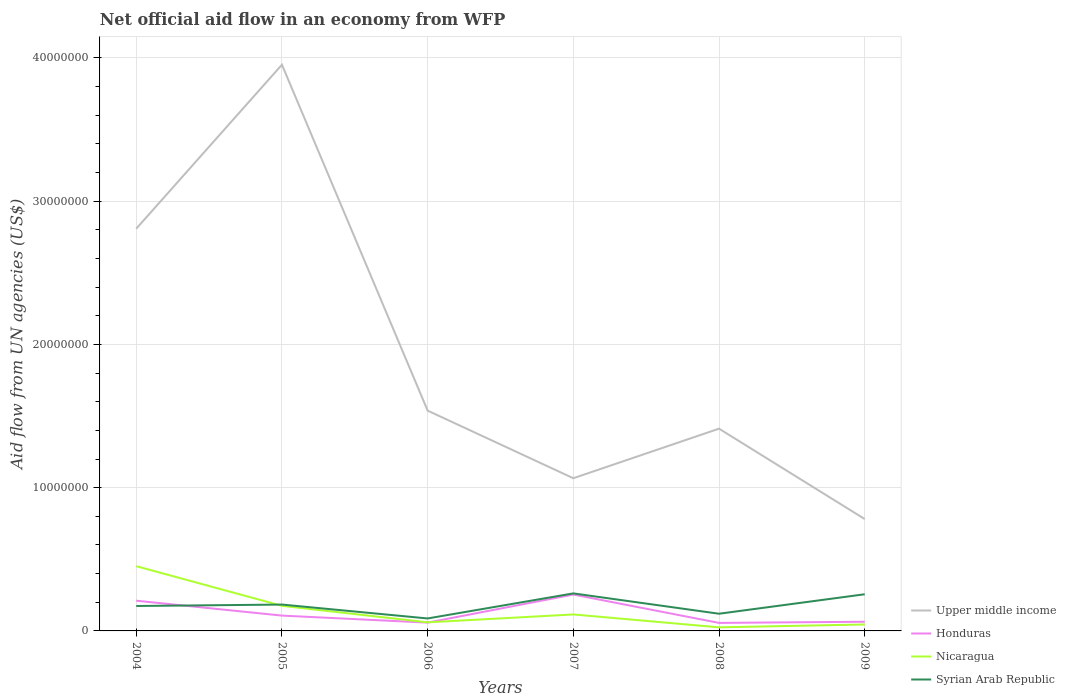Does the line corresponding to Honduras intersect with the line corresponding to Syrian Arab Republic?
Give a very brief answer. Yes. Is the number of lines equal to the number of legend labels?
Ensure brevity in your answer.  Yes. Across all years, what is the maximum net official aid flow in Nicaragua?
Your answer should be compact. 2.50e+05. In which year was the net official aid flow in Nicaragua maximum?
Your response must be concise. 2008. What is the total net official aid flow in Syrian Arab Republic in the graph?
Your answer should be compact. 8.70e+05. What is the difference between the highest and the second highest net official aid flow in Nicaragua?
Make the answer very short. 4.27e+06. What is the difference between the highest and the lowest net official aid flow in Nicaragua?
Make the answer very short. 2. Is the net official aid flow in Honduras strictly greater than the net official aid flow in Nicaragua over the years?
Your response must be concise. No. How many lines are there?
Provide a succinct answer. 4. Are the values on the major ticks of Y-axis written in scientific E-notation?
Provide a short and direct response. No. Does the graph contain any zero values?
Offer a terse response. No. Where does the legend appear in the graph?
Your response must be concise. Bottom right. How many legend labels are there?
Your response must be concise. 4. How are the legend labels stacked?
Your answer should be very brief. Vertical. What is the title of the graph?
Your response must be concise. Net official aid flow in an economy from WFP. Does "Djibouti" appear as one of the legend labels in the graph?
Your answer should be compact. No. What is the label or title of the Y-axis?
Provide a succinct answer. Aid flow from UN agencies (US$). What is the Aid flow from UN agencies (US$) of Upper middle income in 2004?
Your answer should be compact. 2.81e+07. What is the Aid flow from UN agencies (US$) of Honduras in 2004?
Give a very brief answer. 2.11e+06. What is the Aid flow from UN agencies (US$) of Nicaragua in 2004?
Make the answer very short. 4.52e+06. What is the Aid flow from UN agencies (US$) of Syrian Arab Republic in 2004?
Offer a terse response. 1.74e+06. What is the Aid flow from UN agencies (US$) of Upper middle income in 2005?
Your answer should be very brief. 3.95e+07. What is the Aid flow from UN agencies (US$) in Honduras in 2005?
Provide a succinct answer. 1.07e+06. What is the Aid flow from UN agencies (US$) in Nicaragua in 2005?
Make the answer very short. 1.75e+06. What is the Aid flow from UN agencies (US$) in Syrian Arab Republic in 2005?
Give a very brief answer. 1.84e+06. What is the Aid flow from UN agencies (US$) of Upper middle income in 2006?
Your response must be concise. 1.54e+07. What is the Aid flow from UN agencies (US$) in Honduras in 2006?
Provide a succinct answer. 5.80e+05. What is the Aid flow from UN agencies (US$) in Nicaragua in 2006?
Provide a succinct answer. 6.00e+05. What is the Aid flow from UN agencies (US$) of Syrian Arab Republic in 2006?
Your answer should be compact. 8.70e+05. What is the Aid flow from UN agencies (US$) of Upper middle income in 2007?
Your answer should be compact. 1.07e+07. What is the Aid flow from UN agencies (US$) in Honduras in 2007?
Keep it short and to the point. 2.54e+06. What is the Aid flow from UN agencies (US$) of Nicaragua in 2007?
Offer a terse response. 1.15e+06. What is the Aid flow from UN agencies (US$) of Syrian Arab Republic in 2007?
Keep it short and to the point. 2.62e+06. What is the Aid flow from UN agencies (US$) in Upper middle income in 2008?
Offer a very short reply. 1.41e+07. What is the Aid flow from UN agencies (US$) in Honduras in 2008?
Keep it short and to the point. 5.60e+05. What is the Aid flow from UN agencies (US$) in Syrian Arab Republic in 2008?
Keep it short and to the point. 1.20e+06. What is the Aid flow from UN agencies (US$) of Upper middle income in 2009?
Your response must be concise. 7.81e+06. What is the Aid flow from UN agencies (US$) in Honduras in 2009?
Provide a succinct answer. 6.40e+05. What is the Aid flow from UN agencies (US$) of Syrian Arab Republic in 2009?
Make the answer very short. 2.56e+06. Across all years, what is the maximum Aid flow from UN agencies (US$) in Upper middle income?
Offer a very short reply. 3.95e+07. Across all years, what is the maximum Aid flow from UN agencies (US$) of Honduras?
Make the answer very short. 2.54e+06. Across all years, what is the maximum Aid flow from UN agencies (US$) of Nicaragua?
Keep it short and to the point. 4.52e+06. Across all years, what is the maximum Aid flow from UN agencies (US$) in Syrian Arab Republic?
Provide a succinct answer. 2.62e+06. Across all years, what is the minimum Aid flow from UN agencies (US$) in Upper middle income?
Your answer should be compact. 7.81e+06. Across all years, what is the minimum Aid flow from UN agencies (US$) of Honduras?
Provide a short and direct response. 5.60e+05. Across all years, what is the minimum Aid flow from UN agencies (US$) of Syrian Arab Republic?
Keep it short and to the point. 8.70e+05. What is the total Aid flow from UN agencies (US$) of Upper middle income in the graph?
Offer a very short reply. 1.16e+08. What is the total Aid flow from UN agencies (US$) in Honduras in the graph?
Provide a short and direct response. 7.50e+06. What is the total Aid flow from UN agencies (US$) of Nicaragua in the graph?
Give a very brief answer. 8.72e+06. What is the total Aid flow from UN agencies (US$) in Syrian Arab Republic in the graph?
Give a very brief answer. 1.08e+07. What is the difference between the Aid flow from UN agencies (US$) of Upper middle income in 2004 and that in 2005?
Give a very brief answer. -1.14e+07. What is the difference between the Aid flow from UN agencies (US$) of Honduras in 2004 and that in 2005?
Your response must be concise. 1.04e+06. What is the difference between the Aid flow from UN agencies (US$) in Nicaragua in 2004 and that in 2005?
Your response must be concise. 2.77e+06. What is the difference between the Aid flow from UN agencies (US$) in Upper middle income in 2004 and that in 2006?
Ensure brevity in your answer.  1.27e+07. What is the difference between the Aid flow from UN agencies (US$) of Honduras in 2004 and that in 2006?
Provide a succinct answer. 1.53e+06. What is the difference between the Aid flow from UN agencies (US$) of Nicaragua in 2004 and that in 2006?
Your response must be concise. 3.92e+06. What is the difference between the Aid flow from UN agencies (US$) of Syrian Arab Republic in 2004 and that in 2006?
Make the answer very short. 8.70e+05. What is the difference between the Aid flow from UN agencies (US$) of Upper middle income in 2004 and that in 2007?
Give a very brief answer. 1.74e+07. What is the difference between the Aid flow from UN agencies (US$) in Honduras in 2004 and that in 2007?
Ensure brevity in your answer.  -4.30e+05. What is the difference between the Aid flow from UN agencies (US$) of Nicaragua in 2004 and that in 2007?
Offer a terse response. 3.37e+06. What is the difference between the Aid flow from UN agencies (US$) of Syrian Arab Republic in 2004 and that in 2007?
Your response must be concise. -8.80e+05. What is the difference between the Aid flow from UN agencies (US$) in Upper middle income in 2004 and that in 2008?
Provide a succinct answer. 1.40e+07. What is the difference between the Aid flow from UN agencies (US$) of Honduras in 2004 and that in 2008?
Give a very brief answer. 1.55e+06. What is the difference between the Aid flow from UN agencies (US$) in Nicaragua in 2004 and that in 2008?
Offer a very short reply. 4.27e+06. What is the difference between the Aid flow from UN agencies (US$) in Syrian Arab Republic in 2004 and that in 2008?
Ensure brevity in your answer.  5.40e+05. What is the difference between the Aid flow from UN agencies (US$) of Upper middle income in 2004 and that in 2009?
Provide a succinct answer. 2.03e+07. What is the difference between the Aid flow from UN agencies (US$) in Honduras in 2004 and that in 2009?
Keep it short and to the point. 1.47e+06. What is the difference between the Aid flow from UN agencies (US$) of Nicaragua in 2004 and that in 2009?
Provide a short and direct response. 4.07e+06. What is the difference between the Aid flow from UN agencies (US$) in Syrian Arab Republic in 2004 and that in 2009?
Your answer should be compact. -8.20e+05. What is the difference between the Aid flow from UN agencies (US$) in Upper middle income in 2005 and that in 2006?
Keep it short and to the point. 2.42e+07. What is the difference between the Aid flow from UN agencies (US$) in Nicaragua in 2005 and that in 2006?
Make the answer very short. 1.15e+06. What is the difference between the Aid flow from UN agencies (US$) in Syrian Arab Republic in 2005 and that in 2006?
Offer a very short reply. 9.70e+05. What is the difference between the Aid flow from UN agencies (US$) in Upper middle income in 2005 and that in 2007?
Ensure brevity in your answer.  2.89e+07. What is the difference between the Aid flow from UN agencies (US$) in Honduras in 2005 and that in 2007?
Ensure brevity in your answer.  -1.47e+06. What is the difference between the Aid flow from UN agencies (US$) of Syrian Arab Republic in 2005 and that in 2007?
Ensure brevity in your answer.  -7.80e+05. What is the difference between the Aid flow from UN agencies (US$) of Upper middle income in 2005 and that in 2008?
Give a very brief answer. 2.54e+07. What is the difference between the Aid flow from UN agencies (US$) in Honduras in 2005 and that in 2008?
Ensure brevity in your answer.  5.10e+05. What is the difference between the Aid flow from UN agencies (US$) in Nicaragua in 2005 and that in 2008?
Ensure brevity in your answer.  1.50e+06. What is the difference between the Aid flow from UN agencies (US$) of Syrian Arab Republic in 2005 and that in 2008?
Give a very brief answer. 6.40e+05. What is the difference between the Aid flow from UN agencies (US$) of Upper middle income in 2005 and that in 2009?
Keep it short and to the point. 3.17e+07. What is the difference between the Aid flow from UN agencies (US$) of Nicaragua in 2005 and that in 2009?
Provide a short and direct response. 1.30e+06. What is the difference between the Aid flow from UN agencies (US$) of Syrian Arab Republic in 2005 and that in 2009?
Offer a terse response. -7.20e+05. What is the difference between the Aid flow from UN agencies (US$) in Upper middle income in 2006 and that in 2007?
Ensure brevity in your answer.  4.72e+06. What is the difference between the Aid flow from UN agencies (US$) of Honduras in 2006 and that in 2007?
Offer a very short reply. -1.96e+06. What is the difference between the Aid flow from UN agencies (US$) in Nicaragua in 2006 and that in 2007?
Keep it short and to the point. -5.50e+05. What is the difference between the Aid flow from UN agencies (US$) in Syrian Arab Republic in 2006 and that in 2007?
Your answer should be compact. -1.75e+06. What is the difference between the Aid flow from UN agencies (US$) in Upper middle income in 2006 and that in 2008?
Ensure brevity in your answer.  1.26e+06. What is the difference between the Aid flow from UN agencies (US$) in Honduras in 2006 and that in 2008?
Your answer should be compact. 2.00e+04. What is the difference between the Aid flow from UN agencies (US$) of Nicaragua in 2006 and that in 2008?
Offer a terse response. 3.50e+05. What is the difference between the Aid flow from UN agencies (US$) in Syrian Arab Republic in 2006 and that in 2008?
Your response must be concise. -3.30e+05. What is the difference between the Aid flow from UN agencies (US$) of Upper middle income in 2006 and that in 2009?
Offer a terse response. 7.57e+06. What is the difference between the Aid flow from UN agencies (US$) of Honduras in 2006 and that in 2009?
Your response must be concise. -6.00e+04. What is the difference between the Aid flow from UN agencies (US$) of Nicaragua in 2006 and that in 2009?
Your answer should be very brief. 1.50e+05. What is the difference between the Aid flow from UN agencies (US$) of Syrian Arab Republic in 2006 and that in 2009?
Ensure brevity in your answer.  -1.69e+06. What is the difference between the Aid flow from UN agencies (US$) of Upper middle income in 2007 and that in 2008?
Give a very brief answer. -3.46e+06. What is the difference between the Aid flow from UN agencies (US$) in Honduras in 2007 and that in 2008?
Offer a terse response. 1.98e+06. What is the difference between the Aid flow from UN agencies (US$) of Syrian Arab Republic in 2007 and that in 2008?
Your answer should be compact. 1.42e+06. What is the difference between the Aid flow from UN agencies (US$) in Upper middle income in 2007 and that in 2009?
Provide a succinct answer. 2.85e+06. What is the difference between the Aid flow from UN agencies (US$) of Honduras in 2007 and that in 2009?
Keep it short and to the point. 1.90e+06. What is the difference between the Aid flow from UN agencies (US$) in Nicaragua in 2007 and that in 2009?
Provide a short and direct response. 7.00e+05. What is the difference between the Aid flow from UN agencies (US$) in Upper middle income in 2008 and that in 2009?
Your response must be concise. 6.31e+06. What is the difference between the Aid flow from UN agencies (US$) of Nicaragua in 2008 and that in 2009?
Offer a terse response. -2.00e+05. What is the difference between the Aid flow from UN agencies (US$) of Syrian Arab Republic in 2008 and that in 2009?
Ensure brevity in your answer.  -1.36e+06. What is the difference between the Aid flow from UN agencies (US$) of Upper middle income in 2004 and the Aid flow from UN agencies (US$) of Honduras in 2005?
Your answer should be compact. 2.70e+07. What is the difference between the Aid flow from UN agencies (US$) in Upper middle income in 2004 and the Aid flow from UN agencies (US$) in Nicaragua in 2005?
Give a very brief answer. 2.63e+07. What is the difference between the Aid flow from UN agencies (US$) in Upper middle income in 2004 and the Aid flow from UN agencies (US$) in Syrian Arab Republic in 2005?
Provide a succinct answer. 2.62e+07. What is the difference between the Aid flow from UN agencies (US$) of Honduras in 2004 and the Aid flow from UN agencies (US$) of Nicaragua in 2005?
Ensure brevity in your answer.  3.60e+05. What is the difference between the Aid flow from UN agencies (US$) in Nicaragua in 2004 and the Aid flow from UN agencies (US$) in Syrian Arab Republic in 2005?
Your response must be concise. 2.68e+06. What is the difference between the Aid flow from UN agencies (US$) in Upper middle income in 2004 and the Aid flow from UN agencies (US$) in Honduras in 2006?
Offer a very short reply. 2.75e+07. What is the difference between the Aid flow from UN agencies (US$) of Upper middle income in 2004 and the Aid flow from UN agencies (US$) of Nicaragua in 2006?
Your response must be concise. 2.75e+07. What is the difference between the Aid flow from UN agencies (US$) in Upper middle income in 2004 and the Aid flow from UN agencies (US$) in Syrian Arab Republic in 2006?
Offer a very short reply. 2.72e+07. What is the difference between the Aid flow from UN agencies (US$) of Honduras in 2004 and the Aid flow from UN agencies (US$) of Nicaragua in 2006?
Your response must be concise. 1.51e+06. What is the difference between the Aid flow from UN agencies (US$) of Honduras in 2004 and the Aid flow from UN agencies (US$) of Syrian Arab Republic in 2006?
Give a very brief answer. 1.24e+06. What is the difference between the Aid flow from UN agencies (US$) in Nicaragua in 2004 and the Aid flow from UN agencies (US$) in Syrian Arab Republic in 2006?
Provide a short and direct response. 3.65e+06. What is the difference between the Aid flow from UN agencies (US$) of Upper middle income in 2004 and the Aid flow from UN agencies (US$) of Honduras in 2007?
Give a very brief answer. 2.55e+07. What is the difference between the Aid flow from UN agencies (US$) of Upper middle income in 2004 and the Aid flow from UN agencies (US$) of Nicaragua in 2007?
Keep it short and to the point. 2.69e+07. What is the difference between the Aid flow from UN agencies (US$) in Upper middle income in 2004 and the Aid flow from UN agencies (US$) in Syrian Arab Republic in 2007?
Keep it short and to the point. 2.55e+07. What is the difference between the Aid flow from UN agencies (US$) in Honduras in 2004 and the Aid flow from UN agencies (US$) in Nicaragua in 2007?
Provide a succinct answer. 9.60e+05. What is the difference between the Aid flow from UN agencies (US$) in Honduras in 2004 and the Aid flow from UN agencies (US$) in Syrian Arab Republic in 2007?
Make the answer very short. -5.10e+05. What is the difference between the Aid flow from UN agencies (US$) of Nicaragua in 2004 and the Aid flow from UN agencies (US$) of Syrian Arab Republic in 2007?
Give a very brief answer. 1.90e+06. What is the difference between the Aid flow from UN agencies (US$) of Upper middle income in 2004 and the Aid flow from UN agencies (US$) of Honduras in 2008?
Ensure brevity in your answer.  2.75e+07. What is the difference between the Aid flow from UN agencies (US$) of Upper middle income in 2004 and the Aid flow from UN agencies (US$) of Nicaragua in 2008?
Your answer should be compact. 2.78e+07. What is the difference between the Aid flow from UN agencies (US$) of Upper middle income in 2004 and the Aid flow from UN agencies (US$) of Syrian Arab Republic in 2008?
Your response must be concise. 2.69e+07. What is the difference between the Aid flow from UN agencies (US$) in Honduras in 2004 and the Aid flow from UN agencies (US$) in Nicaragua in 2008?
Offer a terse response. 1.86e+06. What is the difference between the Aid flow from UN agencies (US$) of Honduras in 2004 and the Aid flow from UN agencies (US$) of Syrian Arab Republic in 2008?
Offer a very short reply. 9.10e+05. What is the difference between the Aid flow from UN agencies (US$) of Nicaragua in 2004 and the Aid flow from UN agencies (US$) of Syrian Arab Republic in 2008?
Your answer should be compact. 3.32e+06. What is the difference between the Aid flow from UN agencies (US$) of Upper middle income in 2004 and the Aid flow from UN agencies (US$) of Honduras in 2009?
Offer a very short reply. 2.74e+07. What is the difference between the Aid flow from UN agencies (US$) in Upper middle income in 2004 and the Aid flow from UN agencies (US$) in Nicaragua in 2009?
Your response must be concise. 2.76e+07. What is the difference between the Aid flow from UN agencies (US$) in Upper middle income in 2004 and the Aid flow from UN agencies (US$) in Syrian Arab Republic in 2009?
Your answer should be very brief. 2.55e+07. What is the difference between the Aid flow from UN agencies (US$) of Honduras in 2004 and the Aid flow from UN agencies (US$) of Nicaragua in 2009?
Ensure brevity in your answer.  1.66e+06. What is the difference between the Aid flow from UN agencies (US$) in Honduras in 2004 and the Aid flow from UN agencies (US$) in Syrian Arab Republic in 2009?
Make the answer very short. -4.50e+05. What is the difference between the Aid flow from UN agencies (US$) of Nicaragua in 2004 and the Aid flow from UN agencies (US$) of Syrian Arab Republic in 2009?
Make the answer very short. 1.96e+06. What is the difference between the Aid flow from UN agencies (US$) in Upper middle income in 2005 and the Aid flow from UN agencies (US$) in Honduras in 2006?
Give a very brief answer. 3.90e+07. What is the difference between the Aid flow from UN agencies (US$) in Upper middle income in 2005 and the Aid flow from UN agencies (US$) in Nicaragua in 2006?
Provide a succinct answer. 3.89e+07. What is the difference between the Aid flow from UN agencies (US$) of Upper middle income in 2005 and the Aid flow from UN agencies (US$) of Syrian Arab Republic in 2006?
Your answer should be compact. 3.87e+07. What is the difference between the Aid flow from UN agencies (US$) of Honduras in 2005 and the Aid flow from UN agencies (US$) of Nicaragua in 2006?
Make the answer very short. 4.70e+05. What is the difference between the Aid flow from UN agencies (US$) in Nicaragua in 2005 and the Aid flow from UN agencies (US$) in Syrian Arab Republic in 2006?
Make the answer very short. 8.80e+05. What is the difference between the Aid flow from UN agencies (US$) of Upper middle income in 2005 and the Aid flow from UN agencies (US$) of Honduras in 2007?
Provide a succinct answer. 3.70e+07. What is the difference between the Aid flow from UN agencies (US$) of Upper middle income in 2005 and the Aid flow from UN agencies (US$) of Nicaragua in 2007?
Offer a very short reply. 3.84e+07. What is the difference between the Aid flow from UN agencies (US$) of Upper middle income in 2005 and the Aid flow from UN agencies (US$) of Syrian Arab Republic in 2007?
Provide a succinct answer. 3.69e+07. What is the difference between the Aid flow from UN agencies (US$) of Honduras in 2005 and the Aid flow from UN agencies (US$) of Syrian Arab Republic in 2007?
Keep it short and to the point. -1.55e+06. What is the difference between the Aid flow from UN agencies (US$) of Nicaragua in 2005 and the Aid flow from UN agencies (US$) of Syrian Arab Republic in 2007?
Provide a short and direct response. -8.70e+05. What is the difference between the Aid flow from UN agencies (US$) of Upper middle income in 2005 and the Aid flow from UN agencies (US$) of Honduras in 2008?
Provide a short and direct response. 3.90e+07. What is the difference between the Aid flow from UN agencies (US$) in Upper middle income in 2005 and the Aid flow from UN agencies (US$) in Nicaragua in 2008?
Your answer should be compact. 3.93e+07. What is the difference between the Aid flow from UN agencies (US$) of Upper middle income in 2005 and the Aid flow from UN agencies (US$) of Syrian Arab Republic in 2008?
Make the answer very short. 3.83e+07. What is the difference between the Aid flow from UN agencies (US$) in Honduras in 2005 and the Aid flow from UN agencies (US$) in Nicaragua in 2008?
Give a very brief answer. 8.20e+05. What is the difference between the Aid flow from UN agencies (US$) of Honduras in 2005 and the Aid flow from UN agencies (US$) of Syrian Arab Republic in 2008?
Your answer should be very brief. -1.30e+05. What is the difference between the Aid flow from UN agencies (US$) in Nicaragua in 2005 and the Aid flow from UN agencies (US$) in Syrian Arab Republic in 2008?
Give a very brief answer. 5.50e+05. What is the difference between the Aid flow from UN agencies (US$) of Upper middle income in 2005 and the Aid flow from UN agencies (US$) of Honduras in 2009?
Keep it short and to the point. 3.89e+07. What is the difference between the Aid flow from UN agencies (US$) of Upper middle income in 2005 and the Aid flow from UN agencies (US$) of Nicaragua in 2009?
Your answer should be compact. 3.91e+07. What is the difference between the Aid flow from UN agencies (US$) in Upper middle income in 2005 and the Aid flow from UN agencies (US$) in Syrian Arab Republic in 2009?
Make the answer very short. 3.70e+07. What is the difference between the Aid flow from UN agencies (US$) of Honduras in 2005 and the Aid flow from UN agencies (US$) of Nicaragua in 2009?
Offer a very short reply. 6.20e+05. What is the difference between the Aid flow from UN agencies (US$) in Honduras in 2005 and the Aid flow from UN agencies (US$) in Syrian Arab Republic in 2009?
Make the answer very short. -1.49e+06. What is the difference between the Aid flow from UN agencies (US$) of Nicaragua in 2005 and the Aid flow from UN agencies (US$) of Syrian Arab Republic in 2009?
Ensure brevity in your answer.  -8.10e+05. What is the difference between the Aid flow from UN agencies (US$) of Upper middle income in 2006 and the Aid flow from UN agencies (US$) of Honduras in 2007?
Offer a terse response. 1.28e+07. What is the difference between the Aid flow from UN agencies (US$) in Upper middle income in 2006 and the Aid flow from UN agencies (US$) in Nicaragua in 2007?
Make the answer very short. 1.42e+07. What is the difference between the Aid flow from UN agencies (US$) in Upper middle income in 2006 and the Aid flow from UN agencies (US$) in Syrian Arab Republic in 2007?
Your response must be concise. 1.28e+07. What is the difference between the Aid flow from UN agencies (US$) in Honduras in 2006 and the Aid flow from UN agencies (US$) in Nicaragua in 2007?
Your response must be concise. -5.70e+05. What is the difference between the Aid flow from UN agencies (US$) in Honduras in 2006 and the Aid flow from UN agencies (US$) in Syrian Arab Republic in 2007?
Offer a very short reply. -2.04e+06. What is the difference between the Aid flow from UN agencies (US$) in Nicaragua in 2006 and the Aid flow from UN agencies (US$) in Syrian Arab Republic in 2007?
Your response must be concise. -2.02e+06. What is the difference between the Aid flow from UN agencies (US$) in Upper middle income in 2006 and the Aid flow from UN agencies (US$) in Honduras in 2008?
Provide a short and direct response. 1.48e+07. What is the difference between the Aid flow from UN agencies (US$) in Upper middle income in 2006 and the Aid flow from UN agencies (US$) in Nicaragua in 2008?
Your answer should be compact. 1.51e+07. What is the difference between the Aid flow from UN agencies (US$) of Upper middle income in 2006 and the Aid flow from UN agencies (US$) of Syrian Arab Republic in 2008?
Keep it short and to the point. 1.42e+07. What is the difference between the Aid flow from UN agencies (US$) in Honduras in 2006 and the Aid flow from UN agencies (US$) in Syrian Arab Republic in 2008?
Your answer should be compact. -6.20e+05. What is the difference between the Aid flow from UN agencies (US$) in Nicaragua in 2006 and the Aid flow from UN agencies (US$) in Syrian Arab Republic in 2008?
Make the answer very short. -6.00e+05. What is the difference between the Aid flow from UN agencies (US$) in Upper middle income in 2006 and the Aid flow from UN agencies (US$) in Honduras in 2009?
Offer a very short reply. 1.47e+07. What is the difference between the Aid flow from UN agencies (US$) of Upper middle income in 2006 and the Aid flow from UN agencies (US$) of Nicaragua in 2009?
Provide a succinct answer. 1.49e+07. What is the difference between the Aid flow from UN agencies (US$) in Upper middle income in 2006 and the Aid flow from UN agencies (US$) in Syrian Arab Republic in 2009?
Make the answer very short. 1.28e+07. What is the difference between the Aid flow from UN agencies (US$) of Honduras in 2006 and the Aid flow from UN agencies (US$) of Nicaragua in 2009?
Provide a short and direct response. 1.30e+05. What is the difference between the Aid flow from UN agencies (US$) of Honduras in 2006 and the Aid flow from UN agencies (US$) of Syrian Arab Republic in 2009?
Give a very brief answer. -1.98e+06. What is the difference between the Aid flow from UN agencies (US$) in Nicaragua in 2006 and the Aid flow from UN agencies (US$) in Syrian Arab Republic in 2009?
Give a very brief answer. -1.96e+06. What is the difference between the Aid flow from UN agencies (US$) in Upper middle income in 2007 and the Aid flow from UN agencies (US$) in Honduras in 2008?
Keep it short and to the point. 1.01e+07. What is the difference between the Aid flow from UN agencies (US$) in Upper middle income in 2007 and the Aid flow from UN agencies (US$) in Nicaragua in 2008?
Provide a succinct answer. 1.04e+07. What is the difference between the Aid flow from UN agencies (US$) of Upper middle income in 2007 and the Aid flow from UN agencies (US$) of Syrian Arab Republic in 2008?
Your answer should be very brief. 9.46e+06. What is the difference between the Aid flow from UN agencies (US$) in Honduras in 2007 and the Aid flow from UN agencies (US$) in Nicaragua in 2008?
Provide a succinct answer. 2.29e+06. What is the difference between the Aid flow from UN agencies (US$) of Honduras in 2007 and the Aid flow from UN agencies (US$) of Syrian Arab Republic in 2008?
Keep it short and to the point. 1.34e+06. What is the difference between the Aid flow from UN agencies (US$) in Upper middle income in 2007 and the Aid flow from UN agencies (US$) in Honduras in 2009?
Your answer should be very brief. 1.00e+07. What is the difference between the Aid flow from UN agencies (US$) of Upper middle income in 2007 and the Aid flow from UN agencies (US$) of Nicaragua in 2009?
Keep it short and to the point. 1.02e+07. What is the difference between the Aid flow from UN agencies (US$) of Upper middle income in 2007 and the Aid flow from UN agencies (US$) of Syrian Arab Republic in 2009?
Give a very brief answer. 8.10e+06. What is the difference between the Aid flow from UN agencies (US$) in Honduras in 2007 and the Aid flow from UN agencies (US$) in Nicaragua in 2009?
Give a very brief answer. 2.09e+06. What is the difference between the Aid flow from UN agencies (US$) in Honduras in 2007 and the Aid flow from UN agencies (US$) in Syrian Arab Republic in 2009?
Make the answer very short. -2.00e+04. What is the difference between the Aid flow from UN agencies (US$) of Nicaragua in 2007 and the Aid flow from UN agencies (US$) of Syrian Arab Republic in 2009?
Your response must be concise. -1.41e+06. What is the difference between the Aid flow from UN agencies (US$) in Upper middle income in 2008 and the Aid flow from UN agencies (US$) in Honduras in 2009?
Your answer should be very brief. 1.35e+07. What is the difference between the Aid flow from UN agencies (US$) in Upper middle income in 2008 and the Aid flow from UN agencies (US$) in Nicaragua in 2009?
Give a very brief answer. 1.37e+07. What is the difference between the Aid flow from UN agencies (US$) of Upper middle income in 2008 and the Aid flow from UN agencies (US$) of Syrian Arab Republic in 2009?
Keep it short and to the point. 1.16e+07. What is the difference between the Aid flow from UN agencies (US$) of Honduras in 2008 and the Aid flow from UN agencies (US$) of Nicaragua in 2009?
Make the answer very short. 1.10e+05. What is the difference between the Aid flow from UN agencies (US$) of Honduras in 2008 and the Aid flow from UN agencies (US$) of Syrian Arab Republic in 2009?
Your answer should be compact. -2.00e+06. What is the difference between the Aid flow from UN agencies (US$) of Nicaragua in 2008 and the Aid flow from UN agencies (US$) of Syrian Arab Republic in 2009?
Make the answer very short. -2.31e+06. What is the average Aid flow from UN agencies (US$) in Upper middle income per year?
Ensure brevity in your answer.  1.93e+07. What is the average Aid flow from UN agencies (US$) in Honduras per year?
Your answer should be very brief. 1.25e+06. What is the average Aid flow from UN agencies (US$) of Nicaragua per year?
Give a very brief answer. 1.45e+06. What is the average Aid flow from UN agencies (US$) of Syrian Arab Republic per year?
Give a very brief answer. 1.80e+06. In the year 2004, what is the difference between the Aid flow from UN agencies (US$) of Upper middle income and Aid flow from UN agencies (US$) of Honduras?
Your answer should be compact. 2.60e+07. In the year 2004, what is the difference between the Aid flow from UN agencies (US$) in Upper middle income and Aid flow from UN agencies (US$) in Nicaragua?
Your answer should be compact. 2.36e+07. In the year 2004, what is the difference between the Aid flow from UN agencies (US$) of Upper middle income and Aid flow from UN agencies (US$) of Syrian Arab Republic?
Your answer should be very brief. 2.63e+07. In the year 2004, what is the difference between the Aid flow from UN agencies (US$) in Honduras and Aid flow from UN agencies (US$) in Nicaragua?
Keep it short and to the point. -2.41e+06. In the year 2004, what is the difference between the Aid flow from UN agencies (US$) of Nicaragua and Aid flow from UN agencies (US$) of Syrian Arab Republic?
Provide a succinct answer. 2.78e+06. In the year 2005, what is the difference between the Aid flow from UN agencies (US$) in Upper middle income and Aid flow from UN agencies (US$) in Honduras?
Your response must be concise. 3.85e+07. In the year 2005, what is the difference between the Aid flow from UN agencies (US$) of Upper middle income and Aid flow from UN agencies (US$) of Nicaragua?
Provide a succinct answer. 3.78e+07. In the year 2005, what is the difference between the Aid flow from UN agencies (US$) in Upper middle income and Aid flow from UN agencies (US$) in Syrian Arab Republic?
Offer a terse response. 3.77e+07. In the year 2005, what is the difference between the Aid flow from UN agencies (US$) in Honduras and Aid flow from UN agencies (US$) in Nicaragua?
Offer a terse response. -6.80e+05. In the year 2005, what is the difference between the Aid flow from UN agencies (US$) in Honduras and Aid flow from UN agencies (US$) in Syrian Arab Republic?
Ensure brevity in your answer.  -7.70e+05. In the year 2006, what is the difference between the Aid flow from UN agencies (US$) of Upper middle income and Aid flow from UN agencies (US$) of Honduras?
Ensure brevity in your answer.  1.48e+07. In the year 2006, what is the difference between the Aid flow from UN agencies (US$) of Upper middle income and Aid flow from UN agencies (US$) of Nicaragua?
Give a very brief answer. 1.48e+07. In the year 2006, what is the difference between the Aid flow from UN agencies (US$) in Upper middle income and Aid flow from UN agencies (US$) in Syrian Arab Republic?
Provide a short and direct response. 1.45e+07. In the year 2007, what is the difference between the Aid flow from UN agencies (US$) in Upper middle income and Aid flow from UN agencies (US$) in Honduras?
Offer a very short reply. 8.12e+06. In the year 2007, what is the difference between the Aid flow from UN agencies (US$) of Upper middle income and Aid flow from UN agencies (US$) of Nicaragua?
Offer a terse response. 9.51e+06. In the year 2007, what is the difference between the Aid flow from UN agencies (US$) of Upper middle income and Aid flow from UN agencies (US$) of Syrian Arab Republic?
Ensure brevity in your answer.  8.04e+06. In the year 2007, what is the difference between the Aid flow from UN agencies (US$) of Honduras and Aid flow from UN agencies (US$) of Nicaragua?
Give a very brief answer. 1.39e+06. In the year 2007, what is the difference between the Aid flow from UN agencies (US$) in Nicaragua and Aid flow from UN agencies (US$) in Syrian Arab Republic?
Offer a terse response. -1.47e+06. In the year 2008, what is the difference between the Aid flow from UN agencies (US$) of Upper middle income and Aid flow from UN agencies (US$) of Honduras?
Ensure brevity in your answer.  1.36e+07. In the year 2008, what is the difference between the Aid flow from UN agencies (US$) in Upper middle income and Aid flow from UN agencies (US$) in Nicaragua?
Your answer should be compact. 1.39e+07. In the year 2008, what is the difference between the Aid flow from UN agencies (US$) of Upper middle income and Aid flow from UN agencies (US$) of Syrian Arab Republic?
Keep it short and to the point. 1.29e+07. In the year 2008, what is the difference between the Aid flow from UN agencies (US$) in Honduras and Aid flow from UN agencies (US$) in Nicaragua?
Make the answer very short. 3.10e+05. In the year 2008, what is the difference between the Aid flow from UN agencies (US$) in Honduras and Aid flow from UN agencies (US$) in Syrian Arab Republic?
Your answer should be very brief. -6.40e+05. In the year 2008, what is the difference between the Aid flow from UN agencies (US$) in Nicaragua and Aid flow from UN agencies (US$) in Syrian Arab Republic?
Ensure brevity in your answer.  -9.50e+05. In the year 2009, what is the difference between the Aid flow from UN agencies (US$) of Upper middle income and Aid flow from UN agencies (US$) of Honduras?
Provide a succinct answer. 7.17e+06. In the year 2009, what is the difference between the Aid flow from UN agencies (US$) in Upper middle income and Aid flow from UN agencies (US$) in Nicaragua?
Your response must be concise. 7.36e+06. In the year 2009, what is the difference between the Aid flow from UN agencies (US$) of Upper middle income and Aid flow from UN agencies (US$) of Syrian Arab Republic?
Keep it short and to the point. 5.25e+06. In the year 2009, what is the difference between the Aid flow from UN agencies (US$) of Honduras and Aid flow from UN agencies (US$) of Nicaragua?
Offer a very short reply. 1.90e+05. In the year 2009, what is the difference between the Aid flow from UN agencies (US$) in Honduras and Aid flow from UN agencies (US$) in Syrian Arab Republic?
Give a very brief answer. -1.92e+06. In the year 2009, what is the difference between the Aid flow from UN agencies (US$) in Nicaragua and Aid flow from UN agencies (US$) in Syrian Arab Republic?
Ensure brevity in your answer.  -2.11e+06. What is the ratio of the Aid flow from UN agencies (US$) in Upper middle income in 2004 to that in 2005?
Offer a terse response. 0.71. What is the ratio of the Aid flow from UN agencies (US$) of Honduras in 2004 to that in 2005?
Keep it short and to the point. 1.97. What is the ratio of the Aid flow from UN agencies (US$) of Nicaragua in 2004 to that in 2005?
Offer a very short reply. 2.58. What is the ratio of the Aid flow from UN agencies (US$) in Syrian Arab Republic in 2004 to that in 2005?
Keep it short and to the point. 0.95. What is the ratio of the Aid flow from UN agencies (US$) of Upper middle income in 2004 to that in 2006?
Provide a succinct answer. 1.83. What is the ratio of the Aid flow from UN agencies (US$) of Honduras in 2004 to that in 2006?
Provide a short and direct response. 3.64. What is the ratio of the Aid flow from UN agencies (US$) of Nicaragua in 2004 to that in 2006?
Offer a very short reply. 7.53. What is the ratio of the Aid flow from UN agencies (US$) in Syrian Arab Republic in 2004 to that in 2006?
Ensure brevity in your answer.  2. What is the ratio of the Aid flow from UN agencies (US$) of Upper middle income in 2004 to that in 2007?
Offer a very short reply. 2.63. What is the ratio of the Aid flow from UN agencies (US$) of Honduras in 2004 to that in 2007?
Provide a succinct answer. 0.83. What is the ratio of the Aid flow from UN agencies (US$) in Nicaragua in 2004 to that in 2007?
Your answer should be very brief. 3.93. What is the ratio of the Aid flow from UN agencies (US$) of Syrian Arab Republic in 2004 to that in 2007?
Make the answer very short. 0.66. What is the ratio of the Aid flow from UN agencies (US$) of Upper middle income in 2004 to that in 2008?
Keep it short and to the point. 1.99. What is the ratio of the Aid flow from UN agencies (US$) in Honduras in 2004 to that in 2008?
Give a very brief answer. 3.77. What is the ratio of the Aid flow from UN agencies (US$) of Nicaragua in 2004 to that in 2008?
Your answer should be compact. 18.08. What is the ratio of the Aid flow from UN agencies (US$) in Syrian Arab Republic in 2004 to that in 2008?
Make the answer very short. 1.45. What is the ratio of the Aid flow from UN agencies (US$) in Upper middle income in 2004 to that in 2009?
Your answer should be compact. 3.6. What is the ratio of the Aid flow from UN agencies (US$) in Honduras in 2004 to that in 2009?
Offer a terse response. 3.3. What is the ratio of the Aid flow from UN agencies (US$) of Nicaragua in 2004 to that in 2009?
Keep it short and to the point. 10.04. What is the ratio of the Aid flow from UN agencies (US$) in Syrian Arab Republic in 2004 to that in 2009?
Offer a terse response. 0.68. What is the ratio of the Aid flow from UN agencies (US$) in Upper middle income in 2005 to that in 2006?
Give a very brief answer. 2.57. What is the ratio of the Aid flow from UN agencies (US$) in Honduras in 2005 to that in 2006?
Give a very brief answer. 1.84. What is the ratio of the Aid flow from UN agencies (US$) of Nicaragua in 2005 to that in 2006?
Offer a very short reply. 2.92. What is the ratio of the Aid flow from UN agencies (US$) of Syrian Arab Republic in 2005 to that in 2006?
Make the answer very short. 2.11. What is the ratio of the Aid flow from UN agencies (US$) in Upper middle income in 2005 to that in 2007?
Your response must be concise. 3.71. What is the ratio of the Aid flow from UN agencies (US$) of Honduras in 2005 to that in 2007?
Provide a succinct answer. 0.42. What is the ratio of the Aid flow from UN agencies (US$) in Nicaragua in 2005 to that in 2007?
Provide a succinct answer. 1.52. What is the ratio of the Aid flow from UN agencies (US$) in Syrian Arab Republic in 2005 to that in 2007?
Make the answer very short. 0.7. What is the ratio of the Aid flow from UN agencies (US$) in Upper middle income in 2005 to that in 2008?
Your response must be concise. 2.8. What is the ratio of the Aid flow from UN agencies (US$) in Honduras in 2005 to that in 2008?
Your response must be concise. 1.91. What is the ratio of the Aid flow from UN agencies (US$) of Nicaragua in 2005 to that in 2008?
Offer a terse response. 7. What is the ratio of the Aid flow from UN agencies (US$) in Syrian Arab Republic in 2005 to that in 2008?
Provide a succinct answer. 1.53. What is the ratio of the Aid flow from UN agencies (US$) of Upper middle income in 2005 to that in 2009?
Ensure brevity in your answer.  5.06. What is the ratio of the Aid flow from UN agencies (US$) in Honduras in 2005 to that in 2009?
Your response must be concise. 1.67. What is the ratio of the Aid flow from UN agencies (US$) of Nicaragua in 2005 to that in 2009?
Give a very brief answer. 3.89. What is the ratio of the Aid flow from UN agencies (US$) in Syrian Arab Republic in 2005 to that in 2009?
Your answer should be compact. 0.72. What is the ratio of the Aid flow from UN agencies (US$) of Upper middle income in 2006 to that in 2007?
Your answer should be very brief. 1.44. What is the ratio of the Aid flow from UN agencies (US$) in Honduras in 2006 to that in 2007?
Ensure brevity in your answer.  0.23. What is the ratio of the Aid flow from UN agencies (US$) in Nicaragua in 2006 to that in 2007?
Your response must be concise. 0.52. What is the ratio of the Aid flow from UN agencies (US$) in Syrian Arab Republic in 2006 to that in 2007?
Your response must be concise. 0.33. What is the ratio of the Aid flow from UN agencies (US$) in Upper middle income in 2006 to that in 2008?
Offer a terse response. 1.09. What is the ratio of the Aid flow from UN agencies (US$) in Honduras in 2006 to that in 2008?
Your answer should be compact. 1.04. What is the ratio of the Aid flow from UN agencies (US$) of Nicaragua in 2006 to that in 2008?
Offer a terse response. 2.4. What is the ratio of the Aid flow from UN agencies (US$) in Syrian Arab Republic in 2006 to that in 2008?
Keep it short and to the point. 0.72. What is the ratio of the Aid flow from UN agencies (US$) of Upper middle income in 2006 to that in 2009?
Give a very brief answer. 1.97. What is the ratio of the Aid flow from UN agencies (US$) of Honduras in 2006 to that in 2009?
Your response must be concise. 0.91. What is the ratio of the Aid flow from UN agencies (US$) in Syrian Arab Republic in 2006 to that in 2009?
Ensure brevity in your answer.  0.34. What is the ratio of the Aid flow from UN agencies (US$) of Upper middle income in 2007 to that in 2008?
Provide a short and direct response. 0.76. What is the ratio of the Aid flow from UN agencies (US$) of Honduras in 2007 to that in 2008?
Give a very brief answer. 4.54. What is the ratio of the Aid flow from UN agencies (US$) of Syrian Arab Republic in 2007 to that in 2008?
Provide a succinct answer. 2.18. What is the ratio of the Aid flow from UN agencies (US$) in Upper middle income in 2007 to that in 2009?
Your response must be concise. 1.36. What is the ratio of the Aid flow from UN agencies (US$) of Honduras in 2007 to that in 2009?
Give a very brief answer. 3.97. What is the ratio of the Aid flow from UN agencies (US$) of Nicaragua in 2007 to that in 2009?
Give a very brief answer. 2.56. What is the ratio of the Aid flow from UN agencies (US$) in Syrian Arab Republic in 2007 to that in 2009?
Offer a very short reply. 1.02. What is the ratio of the Aid flow from UN agencies (US$) of Upper middle income in 2008 to that in 2009?
Offer a very short reply. 1.81. What is the ratio of the Aid flow from UN agencies (US$) in Nicaragua in 2008 to that in 2009?
Keep it short and to the point. 0.56. What is the ratio of the Aid flow from UN agencies (US$) of Syrian Arab Republic in 2008 to that in 2009?
Make the answer very short. 0.47. What is the difference between the highest and the second highest Aid flow from UN agencies (US$) of Upper middle income?
Provide a succinct answer. 1.14e+07. What is the difference between the highest and the second highest Aid flow from UN agencies (US$) in Nicaragua?
Make the answer very short. 2.77e+06. What is the difference between the highest and the lowest Aid flow from UN agencies (US$) of Upper middle income?
Ensure brevity in your answer.  3.17e+07. What is the difference between the highest and the lowest Aid flow from UN agencies (US$) in Honduras?
Ensure brevity in your answer.  1.98e+06. What is the difference between the highest and the lowest Aid flow from UN agencies (US$) of Nicaragua?
Provide a succinct answer. 4.27e+06. What is the difference between the highest and the lowest Aid flow from UN agencies (US$) in Syrian Arab Republic?
Keep it short and to the point. 1.75e+06. 